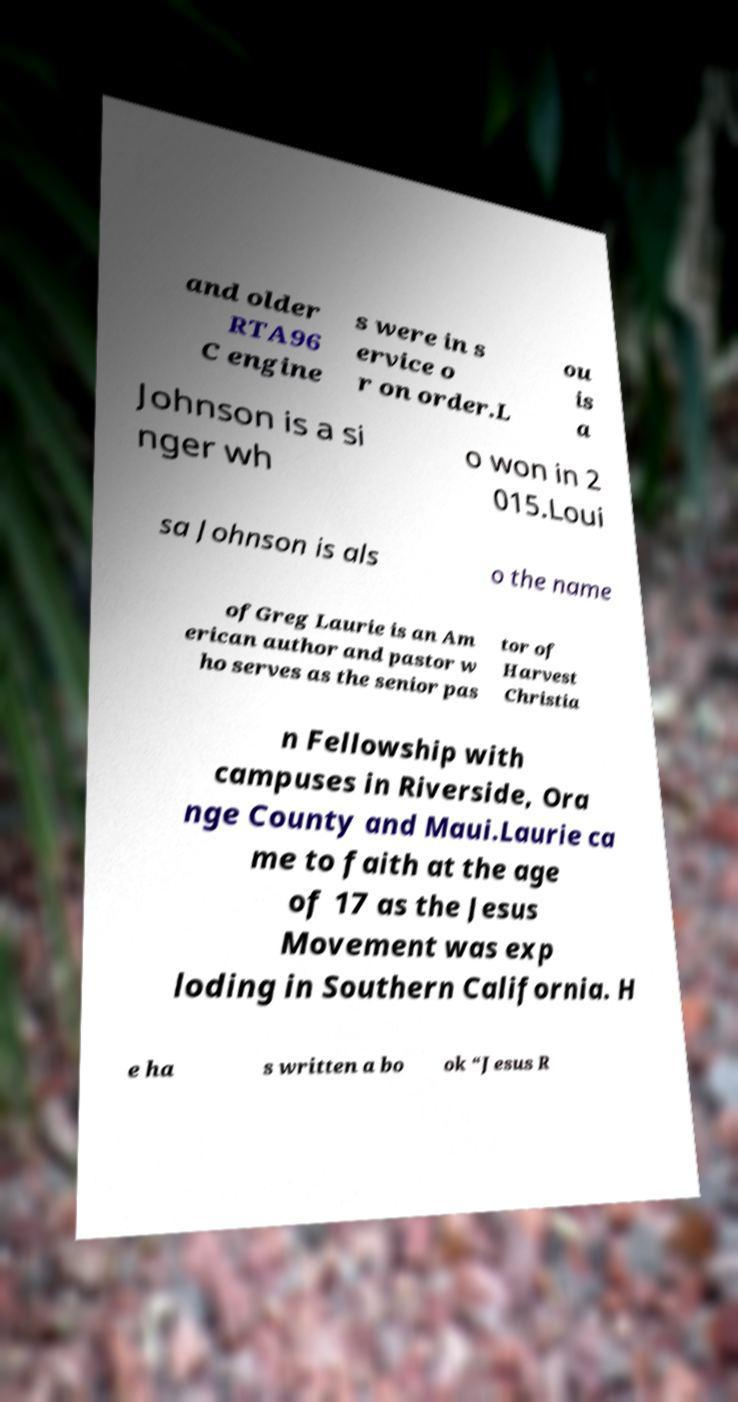Could you extract and type out the text from this image? and older RTA96 C engine s were in s ervice o r on order.L ou is a Johnson is a si nger wh o won in 2 015.Loui sa Johnson is als o the name ofGreg Laurie is an Am erican author and pastor w ho serves as the senior pas tor of Harvest Christia n Fellowship with campuses in Riverside, Ora nge County and Maui.Laurie ca me to faith at the age of 17 as the Jesus Movement was exp loding in Southern California. H e ha s written a bo ok “Jesus R 